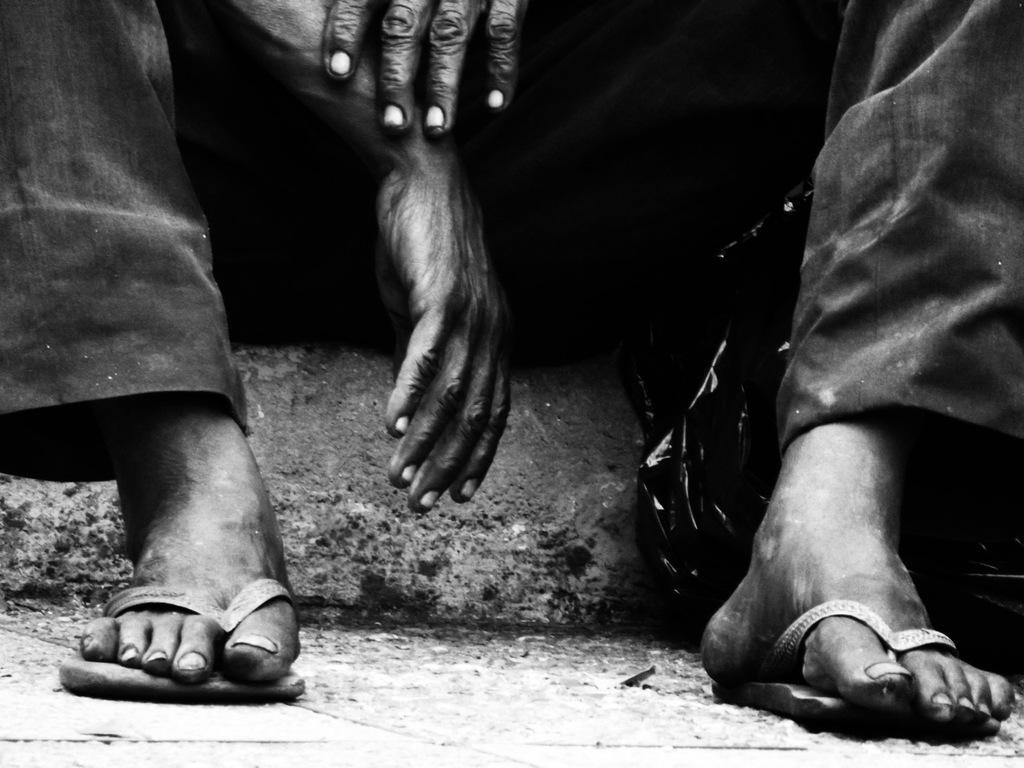Describe this image in one or two sentences. This is a black and white picture. In this picture there is a person sitting we can see the legs and hands. At the bottom it is road. 